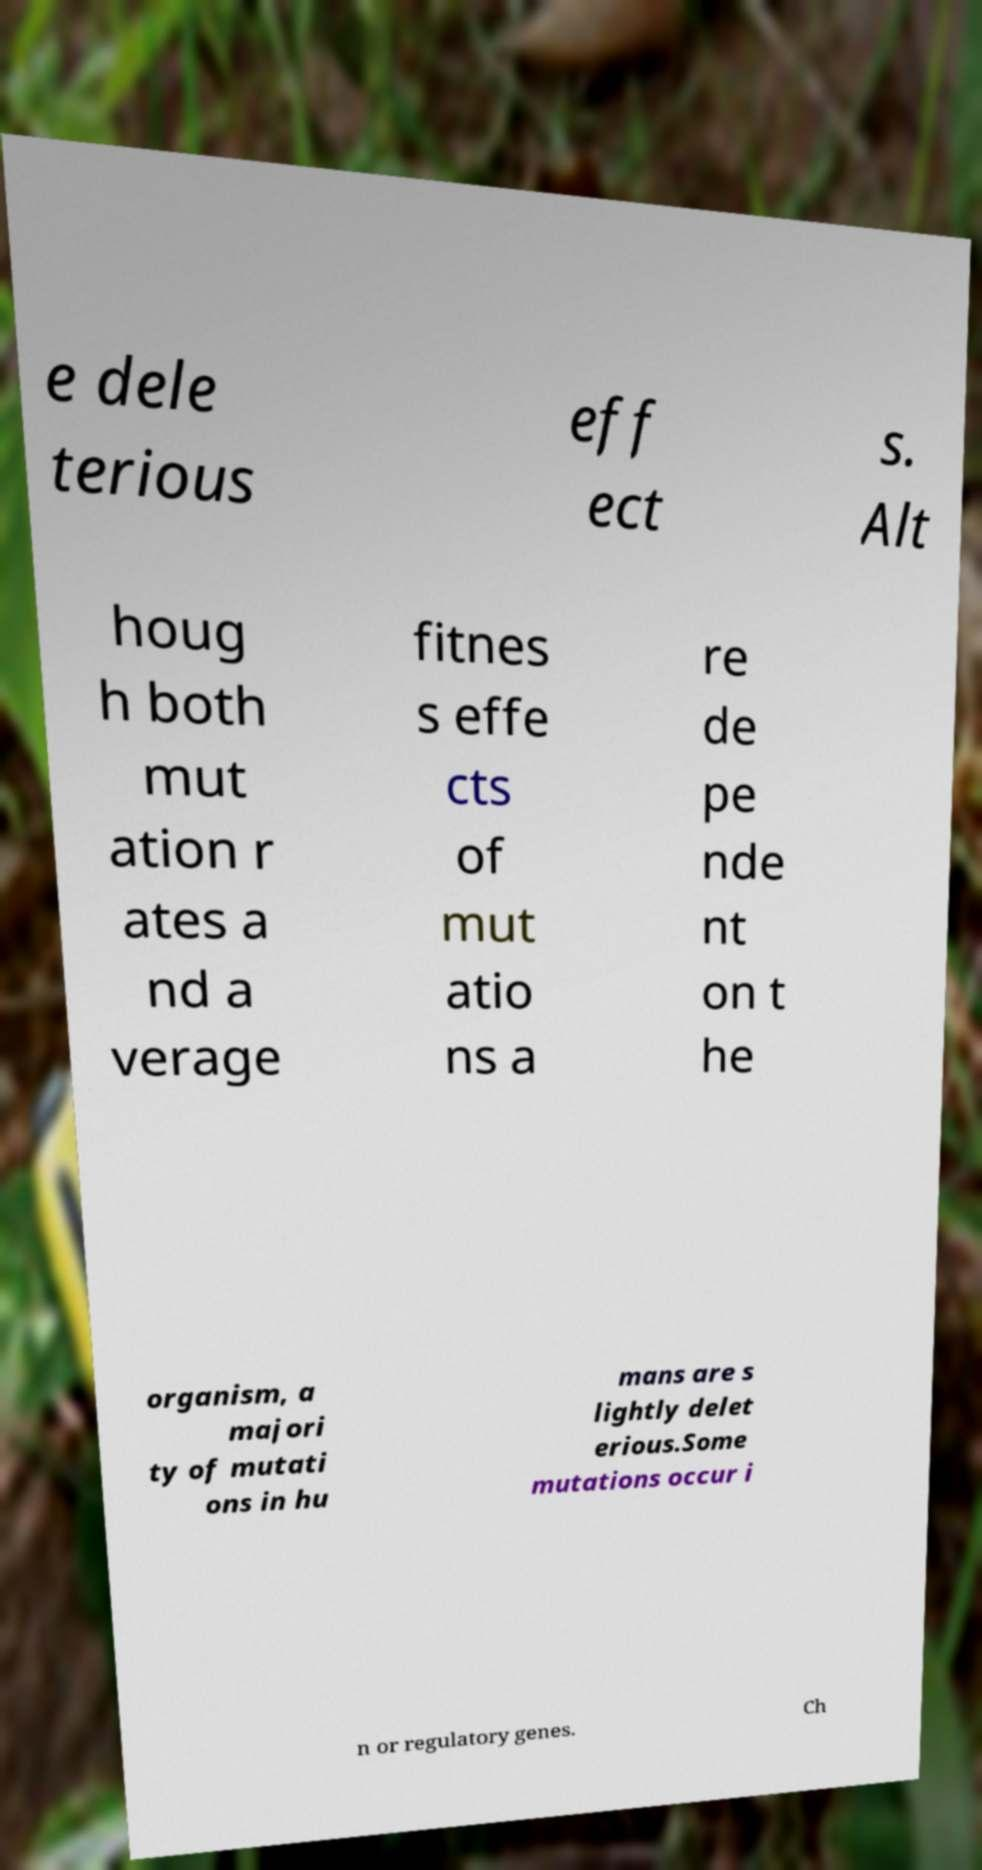There's text embedded in this image that I need extracted. Can you transcribe it verbatim? e dele terious eff ect s. Alt houg h both mut ation r ates a nd a verage fitnes s effe cts of mut atio ns a re de pe nde nt on t he organism, a majori ty of mutati ons in hu mans are s lightly delet erious.Some mutations occur i n or regulatory genes. Ch 